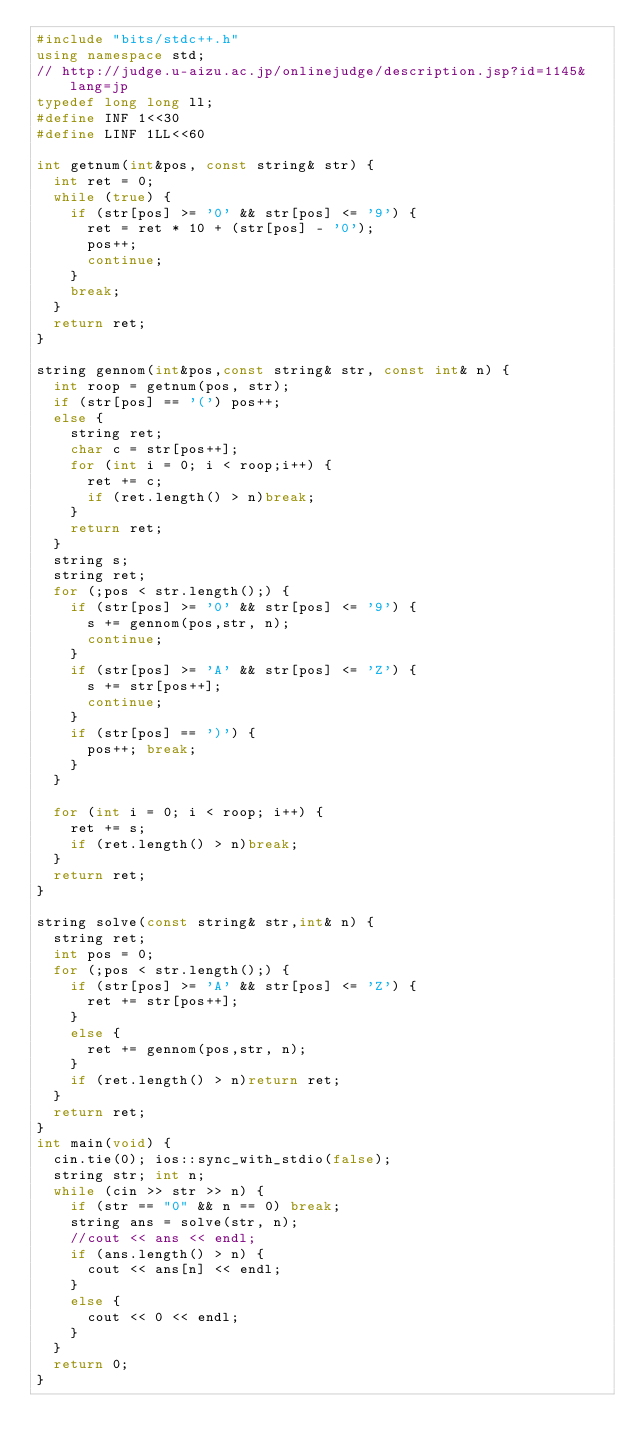<code> <loc_0><loc_0><loc_500><loc_500><_C++_>#include "bits/stdc++.h"
using namespace std;
// http://judge.u-aizu.ac.jp/onlinejudge/description.jsp?id=1145&lang=jp
typedef long long ll;
#define INF 1<<30
#define LINF 1LL<<60

int getnum(int&pos, const string& str) {
	int ret = 0;
	while (true) {
		if (str[pos] >= '0' && str[pos] <= '9') {
			ret = ret * 10 + (str[pos] - '0');
			pos++;
			continue;
		}
		break;
	}
	return ret;
}

string gennom(int&pos,const string& str, const int& n) {
	int roop = getnum(pos, str);
	if (str[pos] == '(') pos++;
	else {
		string ret;
		char c = str[pos++];
		for (int i = 0; i < roop;i++) {
			ret += c;
			if (ret.length() > n)break;
		}
		return ret;
	}
	string s;
	string ret;
	for (;pos < str.length();) {
		if (str[pos] >= '0' && str[pos] <= '9') {
			s += gennom(pos,str, n);
			continue;
		}
		if (str[pos] >= 'A' && str[pos] <= 'Z') {
			s += str[pos++];
			continue;
		}
		if (str[pos] == ')') {
			pos++; break;
		}
	}

	for (int i = 0; i < roop; i++) {
		ret += s;
		if (ret.length() > n)break;
	}
	return ret;
}

string solve(const string& str,int& n) {
	string ret;
	int pos = 0;
	for (;pos < str.length();) {
		if (str[pos] >= 'A' && str[pos] <= 'Z') {
			ret += str[pos++];
		}
		else {
			ret += gennom(pos,str, n);
		}
		if (ret.length() > n)return ret;
	}
	return ret;
}
int main(void) {
	cin.tie(0); ios::sync_with_stdio(false);
	string str; int n;
	while (cin >> str >> n) {
		if (str == "0" && n == 0) break;
		string ans = solve(str, n);
		//cout << ans << endl;
		if (ans.length() > n) {
			cout << ans[n] << endl;
		}
		else {
			cout << 0 << endl;
		}
	}
	return 0;
}</code> 